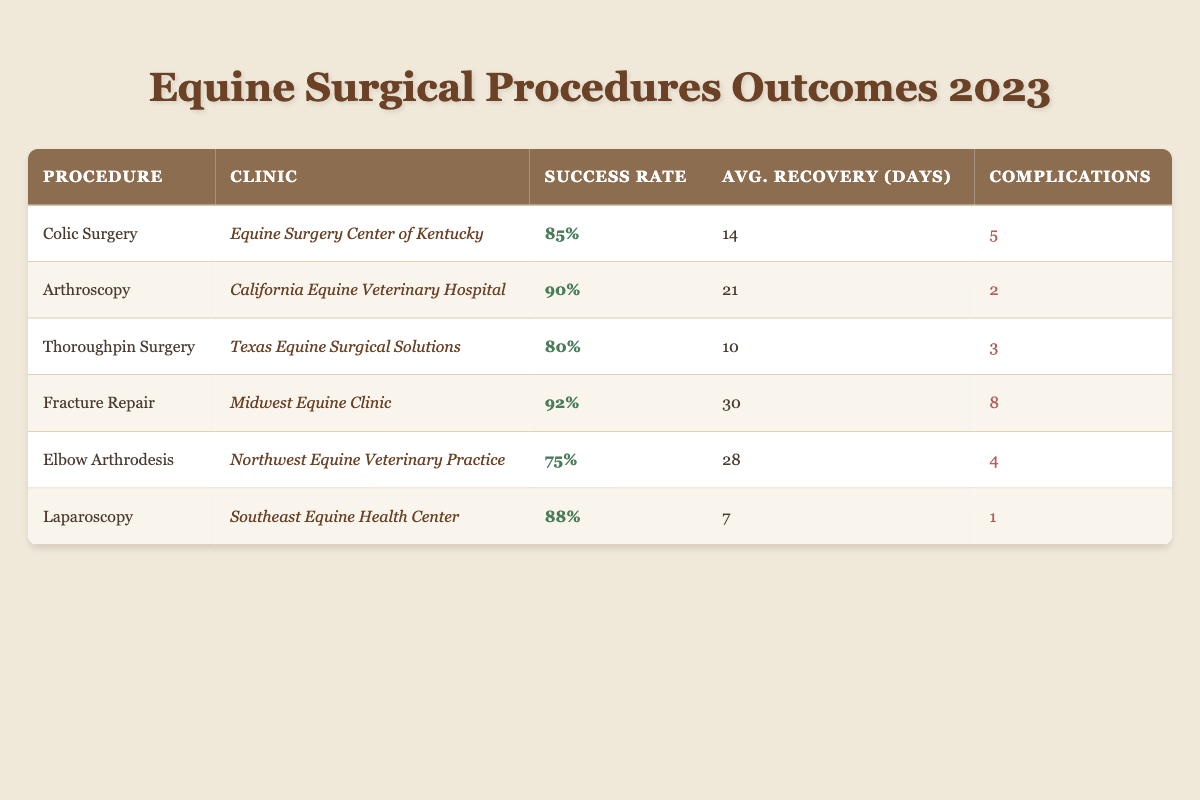What is the success rate for Fracture Repair at the Midwest Equine Clinic? The table shows that the success rate for Fracture Repair at the Midwest Equine Clinic is listed as 92%.
Answer: 92% Which procedure has the lowest success rate? By examining the success rates across all procedures, it is determined that Elbow Arthrodesis has the lowest success rate at 75%.
Answer: Elbow Arthrodesis What is the total number of complications across all procedures? To find the total complications, we need to sum the complications: 5 (Colic Surgery) + 2 (Arthroscopy) + 3 (Thoroughpin Surgery) + 8 (Fracture Repair) + 4 (Elbow Arthrodesis) + 1 (Laparoscopy) = 23 complications in total.
Answer: 23 What is the average recovery time among all procedures? First, add the average recovery times: 14 + 21 + 10 + 30 + 28 + 7 = 110 days. There are 6 total procedures, so the average recovery time is 110/6 ≈ 18.33 days.
Answer: 18.33 Is the success rate for Laparoscopy higher than that for Colic Surgery? Comparing values from the table, Laparoscopy has a success rate of 88% while Colic Surgery has a success rate of 85%. Yes, Laparoscopy is higher.
Answer: Yes Which procedure, performed at which clinic, has the shortest average recovery time? Looking at the table, Laparoscopy at the Southeast Equine Health Center has the shortest average recovery time of 7 days.
Answer: Laparoscopy at Southeast Equine Health Center What is the difference in success rates between Arthroscopy and Thoroughpin Surgery? The success rate for Arthroscopy is 90%, while Thoroughpin Surgery is 80%. The difference is 90 - 80 = 10%.
Answer: 10% Which clinic performed a procedure with exactly 3 complications? By checking the complications column, Texas Equine Surgical Solutions performed Thoroughpin Surgery, which has exactly 3 complications.
Answer: Texas Equine Surgical Solutions What is the highest complication rate for any procedure listed? The complications for each procedure are: 5 (Colic Surgery), 2 (Arthroscopy), 3 (Thoroughpin Surgery), 8 (Fracture Repair), 4 (Elbow Arthrodesis), and 1 (Laparoscopy). The highest complications are 8 for Fracture Repair.
Answer: 8 